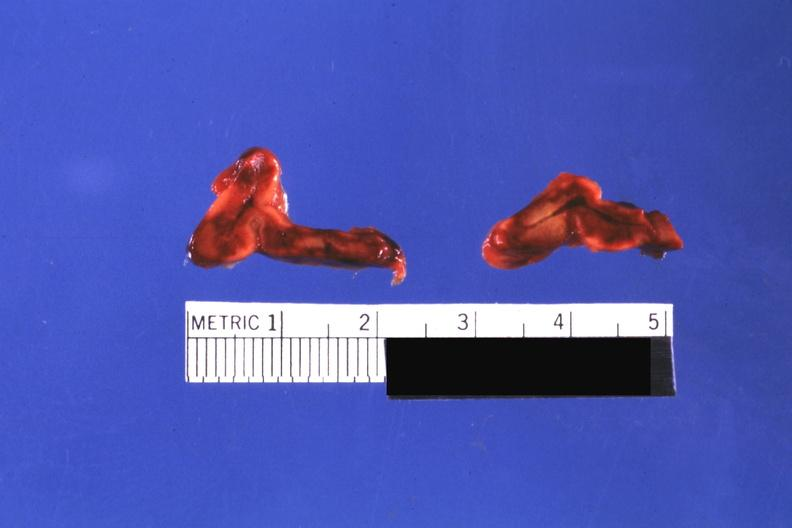what is present?
Answer the question using a single word or phrase. Hemorrhage newborn 